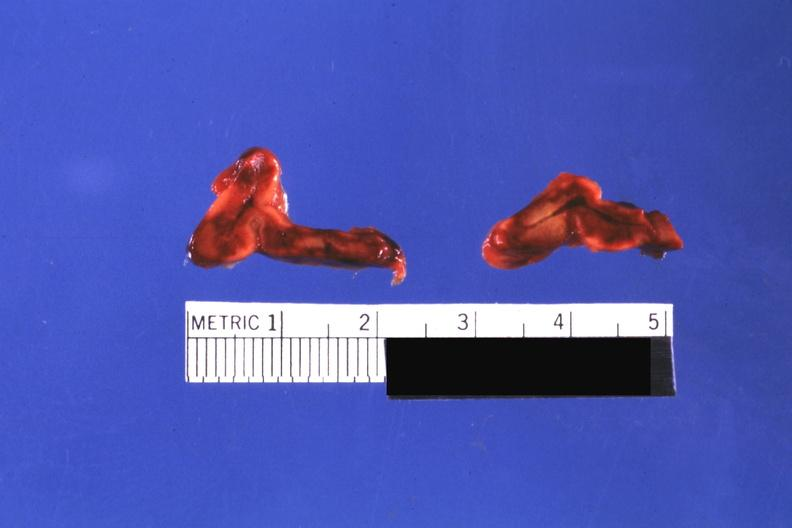what is present?
Answer the question using a single word or phrase. Hemorrhage newborn 